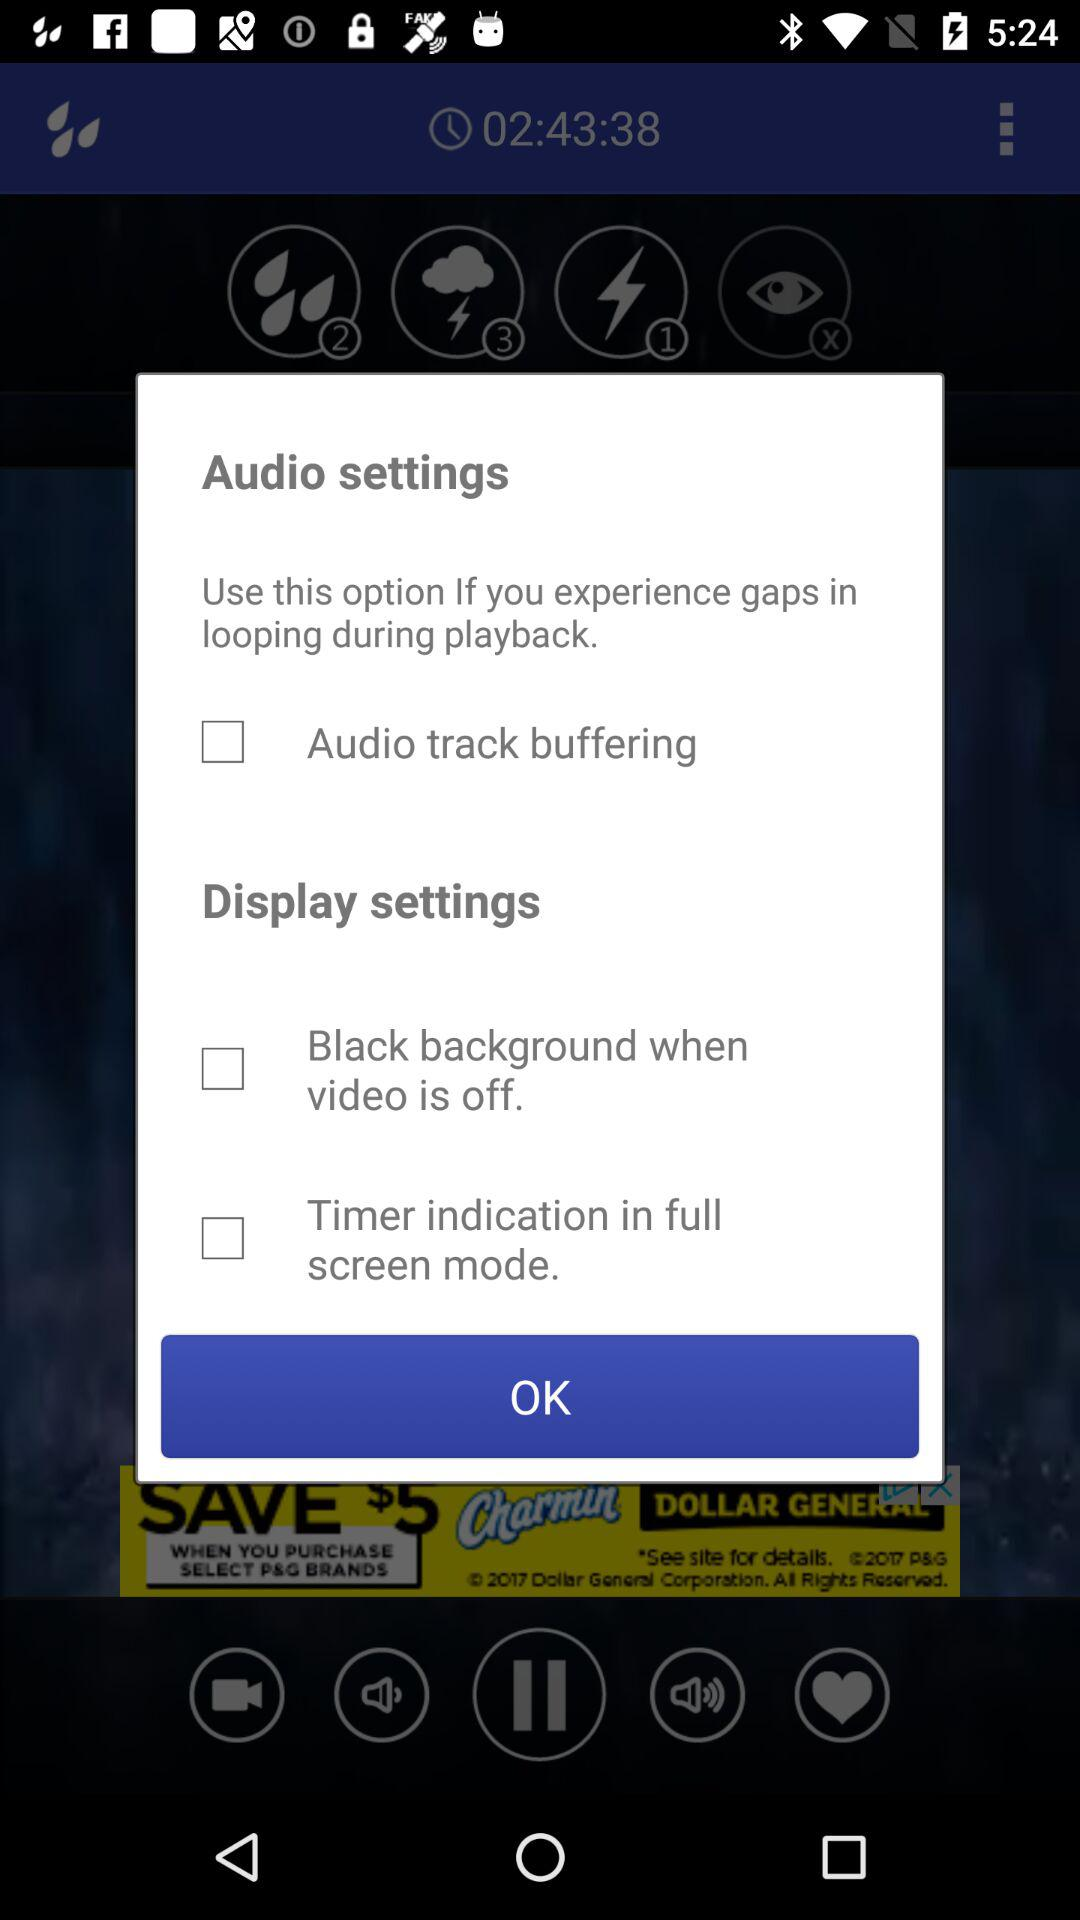How long is the video?
When the provided information is insufficient, respond with <no answer>. <no answer> 